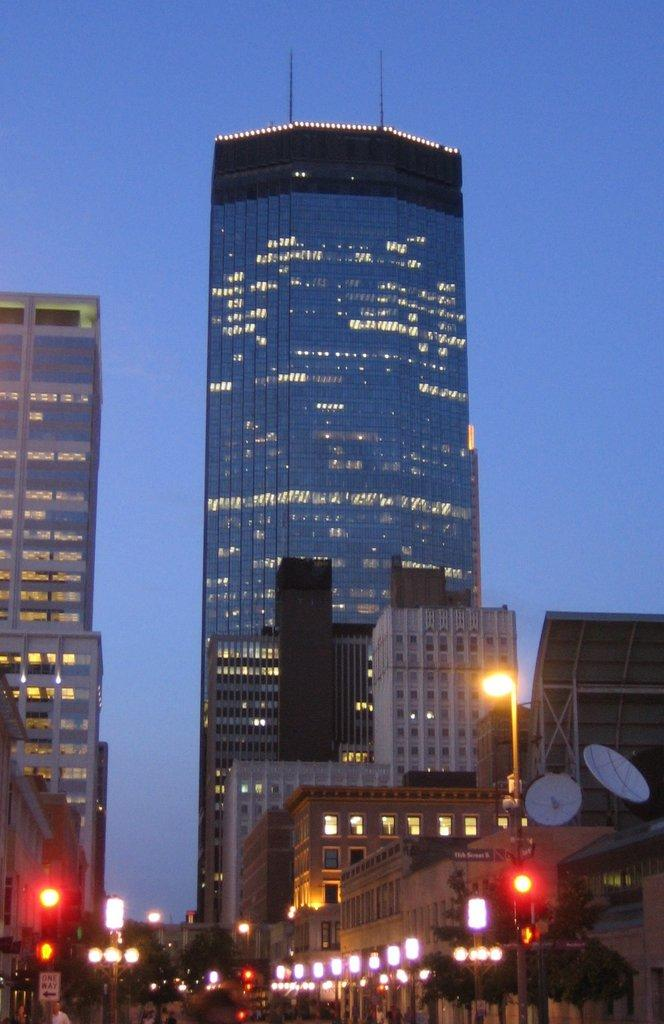What structures can be seen at the bottom of the image? There are light poles and trees at the bottom of the image. Are there any living beings visible in the image? Yes, there are people visible in the image. What type of information might be conveyed by the sign board in the image? The sign board in the image has text, which might convey information or directions. What can be seen in the background of the image? Buildings with windows and the sky are visible in the background. What type of creature is causing trouble in the image? There is no creature present in the image, and no trouble is depicted. How does the sign board show respect in the image? The sign board in the image does not show respect; it simply displays text. 